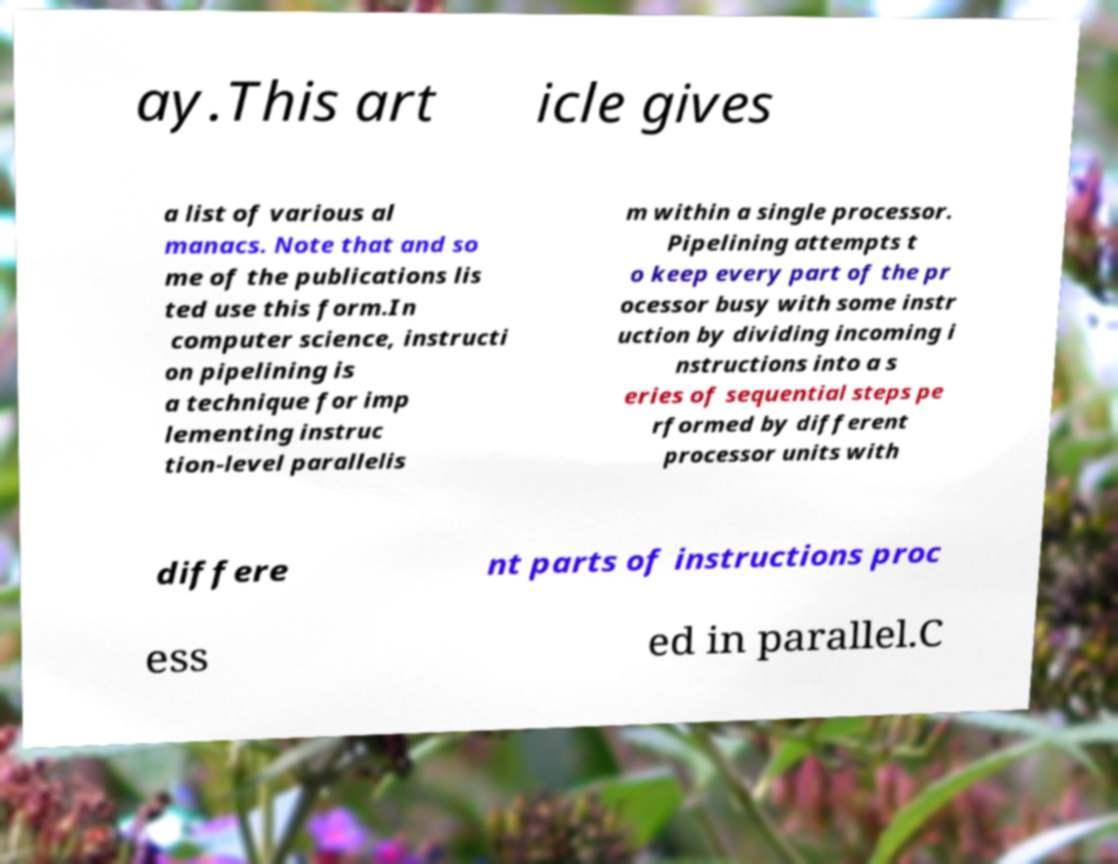Could you extract and type out the text from this image? ay.This art icle gives a list of various al manacs. Note that and so me of the publications lis ted use this form.In computer science, instructi on pipelining is a technique for imp lementing instruc tion-level parallelis m within a single processor. Pipelining attempts t o keep every part of the pr ocessor busy with some instr uction by dividing incoming i nstructions into a s eries of sequential steps pe rformed by different processor units with differe nt parts of instructions proc ess ed in parallel.C 